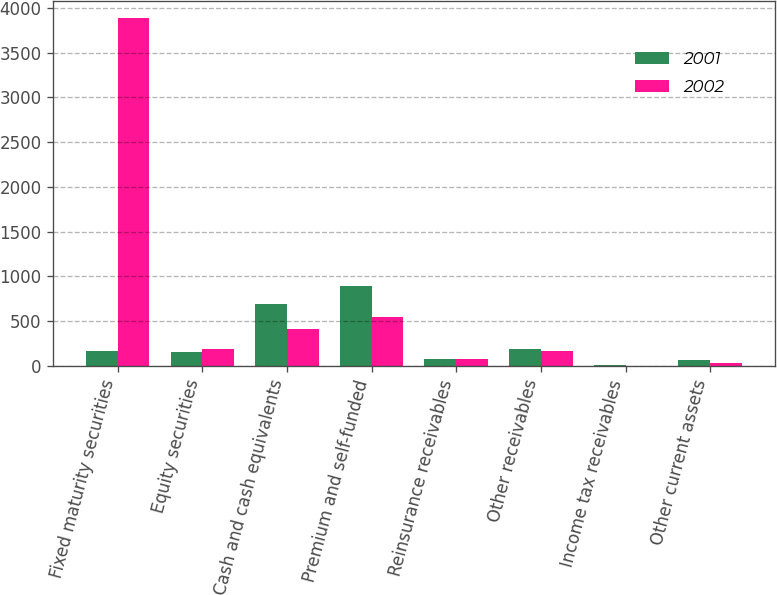<chart> <loc_0><loc_0><loc_500><loc_500><stacked_bar_chart><ecel><fcel>Fixed maturity securities<fcel>Equity securities<fcel>Cash and cash equivalents<fcel>Premium and self-funded<fcel>Reinsurance receivables<fcel>Other receivables<fcel>Income tax receivables<fcel>Other current assets<nl><fcel>2001<fcel>169.1<fcel>150.7<fcel>694.9<fcel>892.7<fcel>76.5<fcel>192.3<fcel>11.7<fcel>60.3<nl><fcel>2002<fcel>3882.7<fcel>189.1<fcel>406.4<fcel>544.7<fcel>76.7<fcel>169.1<fcel>0.4<fcel>30.8<nl></chart> 